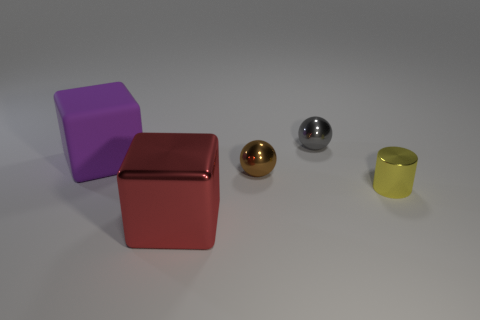Is the number of small metal things in front of the tiny gray object less than the number of yellow metallic cylinders on the right side of the yellow shiny thing?
Provide a succinct answer. No. What number of cylinders have the same color as the large metallic cube?
Keep it short and to the point. 0. What number of big blocks are on the left side of the red cube and in front of the yellow cylinder?
Offer a very short reply. 0. The cube that is to the left of the large block right of the large purple object is made of what material?
Keep it short and to the point. Rubber. Is there a small cyan sphere made of the same material as the gray object?
Make the answer very short. No. There is another object that is the same size as the red metallic object; what is its material?
Give a very brief answer. Rubber. There is a metallic ball that is behind the large block that is left of the red metal block in front of the small gray thing; what size is it?
Keep it short and to the point. Small. Is there a red block in front of the large object that is behind the small yellow shiny object?
Ensure brevity in your answer.  Yes. Do the big purple matte thing and the small metal thing that is behind the large purple rubber thing have the same shape?
Offer a terse response. No. There is a metal thing in front of the yellow cylinder; what color is it?
Provide a short and direct response. Red. 